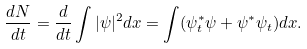<formula> <loc_0><loc_0><loc_500><loc_500>\frac { d N } { d t } = \frac { d } { d t } \int | \psi | ^ { 2 } d x = \int ( \psi ^ { * } _ { t } \psi + \psi ^ { * } \psi _ { t } ) d x .</formula> 